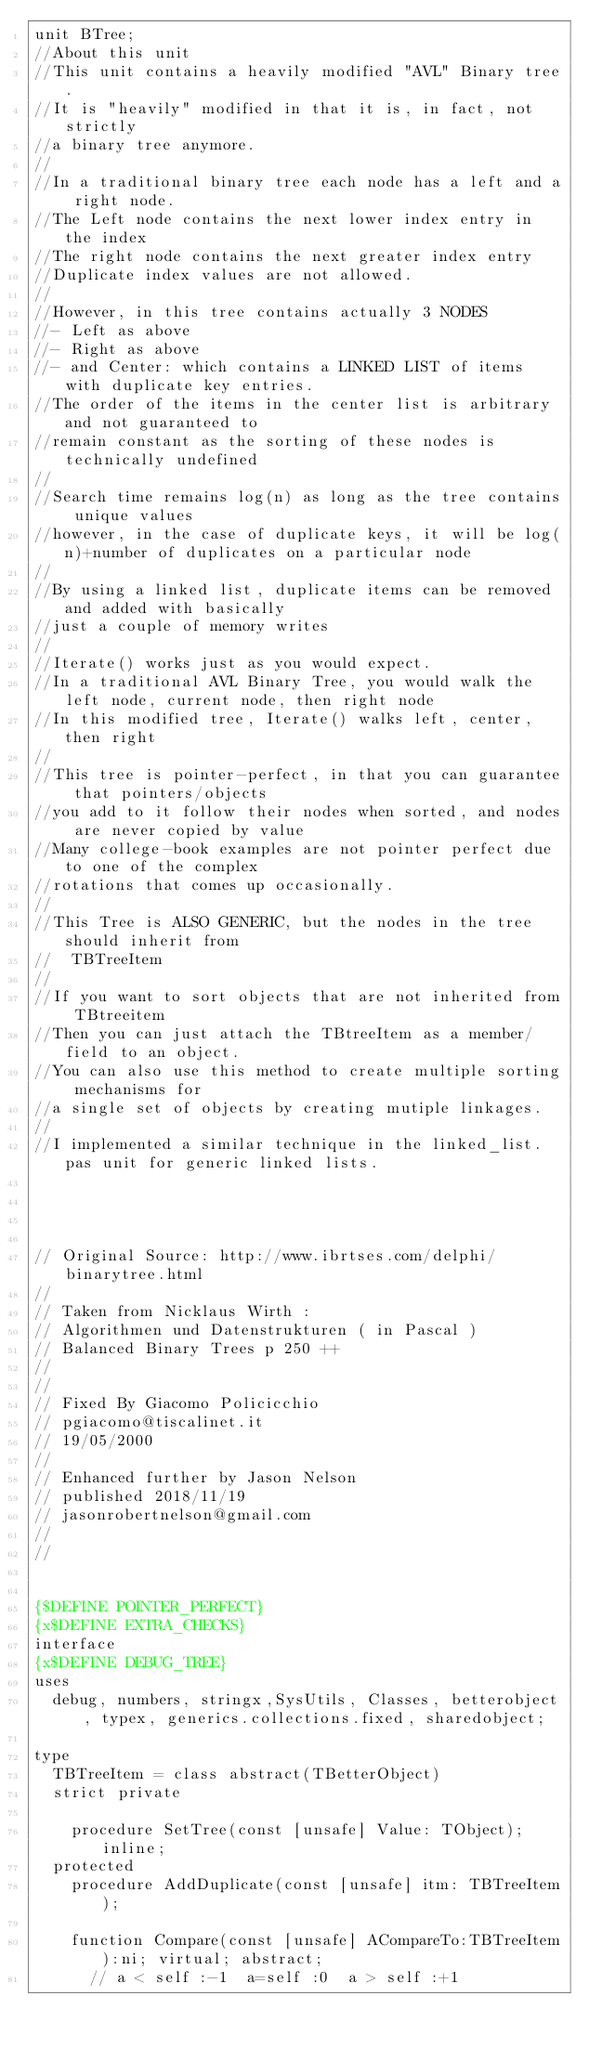<code> <loc_0><loc_0><loc_500><loc_500><_Pascal_>unit BTree;
//About this unit
//This unit contains a heavily modified "AVL" Binary tree.
//It is "heavily" modified in that it is, in fact, not strictly
//a binary tree anymore.
//
//In a traditional binary tree each node has a left and a right node.
//The Left node contains the next lower index entry in the index
//The right node contains the next greater index entry
//Duplicate index values are not allowed.
//
//However, in this tree contains actually 3 NODES
//- Left as above
//- Right as above
//- and Center: which contains a LINKED LIST of items with duplicate key entries.
//The order of the items in the center list is arbitrary and not guaranteed to
//remain constant as the sorting of these nodes is technically undefined
//
//Search time remains log(n) as long as the tree contains unique values
//however, in the case of duplicate keys, it will be log(n)+number of duplicates on a particular node
//
//By using a linked list, duplicate items can be removed and added with basically
//just a couple of memory writes
//
//Iterate() works just as you would expect.
//In a traditional AVL Binary Tree, you would walk the left node, current node, then right node
//In this modified tree, Iterate() walks left, center, then right
//
//This tree is pointer-perfect, in that you can guarantee that pointers/objects
//you add to it follow their nodes when sorted, and nodes are never copied by value
//Many college-book examples are not pointer perfect due to one of the complex
//rotations that comes up occasionally.
//
//This Tree is ALSO GENERIC, but the nodes in the tree should inherit from
//  TBTreeItem
//
//If you want to sort objects that are not inherited from TBtreeitem
//Then you can just attach the TBtreeItem as a member/field to an object.
//You can also use this method to create multiple sorting mechanisms for
//a single set of objects by creating mutiple linkages.
//
//I implemented a similar technique in the linked_list.pas unit for generic linked lists.




// Original Source: http://www.ibrtses.com/delphi/binarytree.html
//
// Taken from Nicklaus Wirth :
// Algorithmen und Datenstrukturen ( in Pascal )
// Balanced Binary Trees p 250 ++
//
//
// Fixed By Giacomo Policicchio
// pgiacomo@tiscalinet.it
// 19/05/2000
//
// Enhanced further by Jason Nelson
// published 2018/11/19
// jasonrobertnelson@gmail.com
//
//


{$DEFINE POINTER_PERFECT}
{x$DEFINE EXTRA_CHECKS}
interface
{x$DEFINE DEBUG_TREE}
uses
  debug, numbers, stringx,SysUtils, Classes, betterobject, typex, generics.collections.fixed, sharedobject;

type
  TBTreeItem = class abstract(TBetterObject)
  strict private

    procedure SetTree(const [unsafe] Value: TObject);inline;
  protected
    procedure AddDuplicate(const [unsafe] itm: TBTreeItem);

    function Compare(const [unsafe] ACompareTo:TBTreeItem):ni; virtual; abstract;
      // a < self :-1  a=self :0  a > self :+1
</code> 